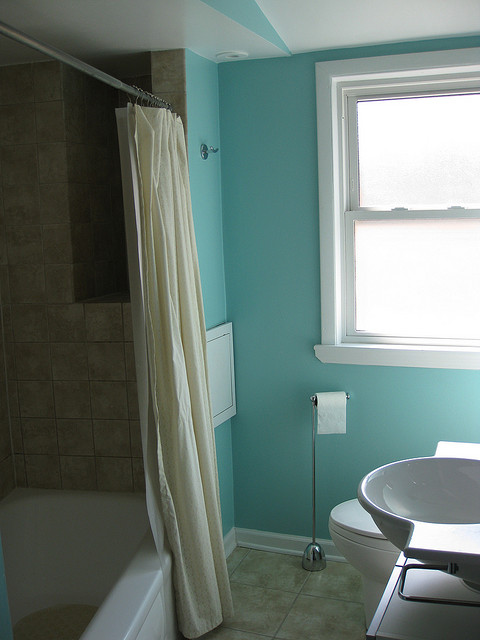<image>How many tissues are there? I don't know how many tissues are there. It can be seen 1 tissue or half roll. How many tissues are there? It is uncertain how many tissues are there. There can be one or more. 